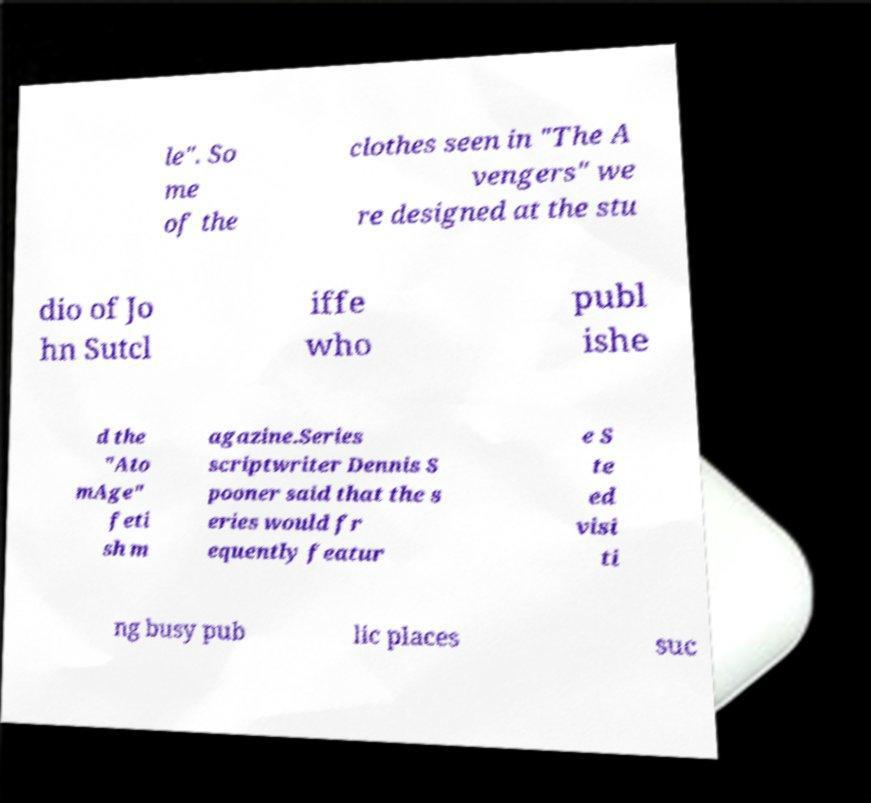I need the written content from this picture converted into text. Can you do that? le". So me of the clothes seen in "The A vengers" we re designed at the stu dio of Jo hn Sutcl iffe who publ ishe d the "Ato mAge" feti sh m agazine.Series scriptwriter Dennis S pooner said that the s eries would fr equently featur e S te ed visi ti ng busy pub lic places suc 